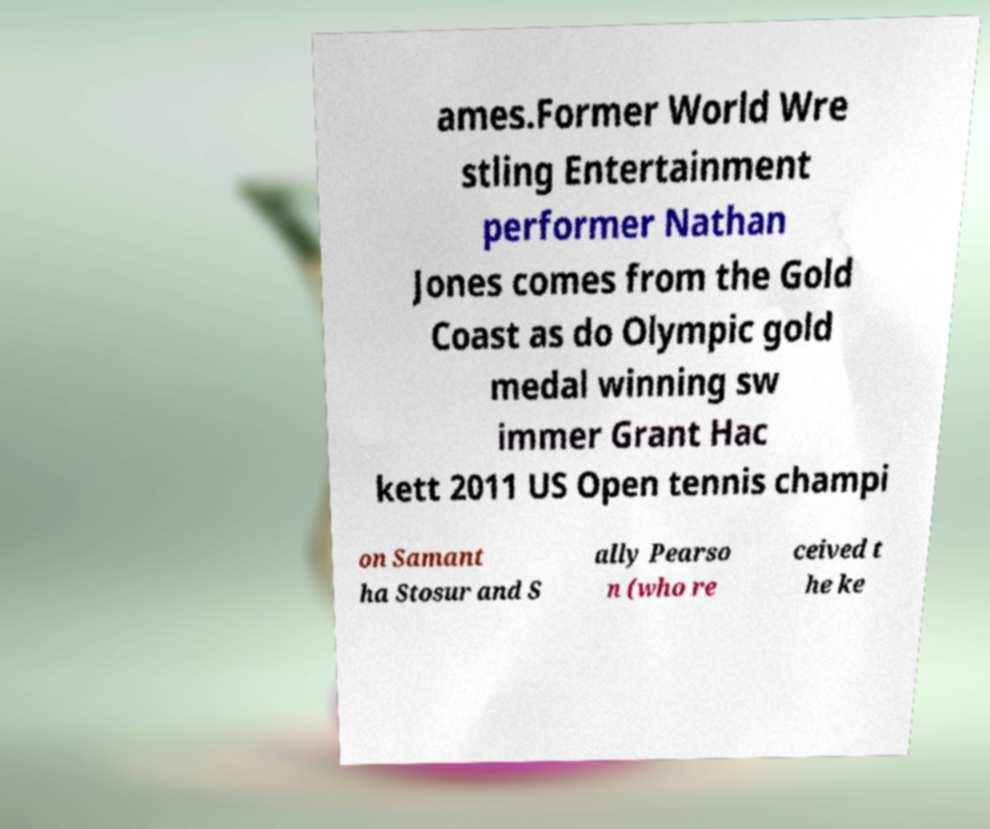There's text embedded in this image that I need extracted. Can you transcribe it verbatim? ames.Former World Wre stling Entertainment performer Nathan Jones comes from the Gold Coast as do Olympic gold medal winning sw immer Grant Hac kett 2011 US Open tennis champi on Samant ha Stosur and S ally Pearso n (who re ceived t he ke 